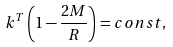Convert formula to latex. <formula><loc_0><loc_0><loc_500><loc_500>k ^ { T } \left ( 1 - \frac { 2 M } { R } \right ) = c o n s t , \\</formula> 